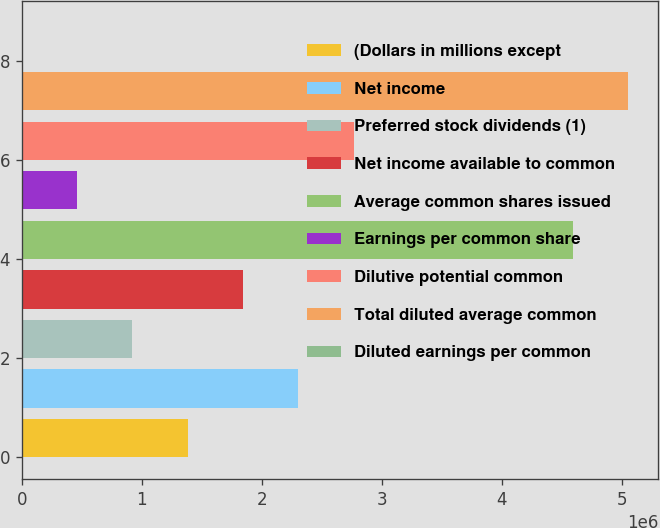<chart> <loc_0><loc_0><loc_500><loc_500><bar_chart><fcel>(Dollars in millions except<fcel>Net income<fcel>Preferred stock dividends (1)<fcel>Net income available to common<fcel>Average common shares issued<fcel>Earnings per common share<fcel>Dilutive potential common<fcel>Total diluted average common<fcel>Diluted earnings per common<nl><fcel>1.38375e+06<fcel>2.30625e+06<fcel>922499<fcel>1.845e+06<fcel>4.59208e+06<fcel>461250<fcel>2.76749e+06<fcel>5.05333e+06<fcel>0.55<nl></chart> 